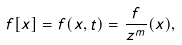<formula> <loc_0><loc_0><loc_500><loc_500>f [ x ] = f ( x , t ) = \frac { f } { z ^ { m } } ( x ) ,</formula> 